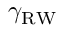<formula> <loc_0><loc_0><loc_500><loc_500>\gamma _ { R W }</formula> 